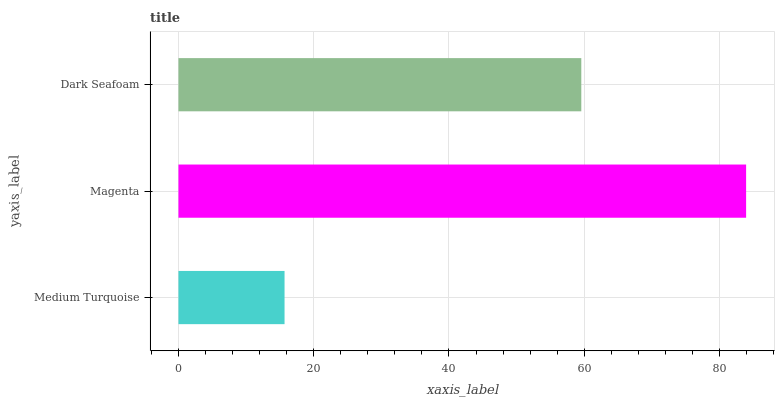Is Medium Turquoise the minimum?
Answer yes or no. Yes. Is Magenta the maximum?
Answer yes or no. Yes. Is Dark Seafoam the minimum?
Answer yes or no. No. Is Dark Seafoam the maximum?
Answer yes or no. No. Is Magenta greater than Dark Seafoam?
Answer yes or no. Yes. Is Dark Seafoam less than Magenta?
Answer yes or no. Yes. Is Dark Seafoam greater than Magenta?
Answer yes or no. No. Is Magenta less than Dark Seafoam?
Answer yes or no. No. Is Dark Seafoam the high median?
Answer yes or no. Yes. Is Dark Seafoam the low median?
Answer yes or no. Yes. Is Magenta the high median?
Answer yes or no. No. Is Magenta the low median?
Answer yes or no. No. 